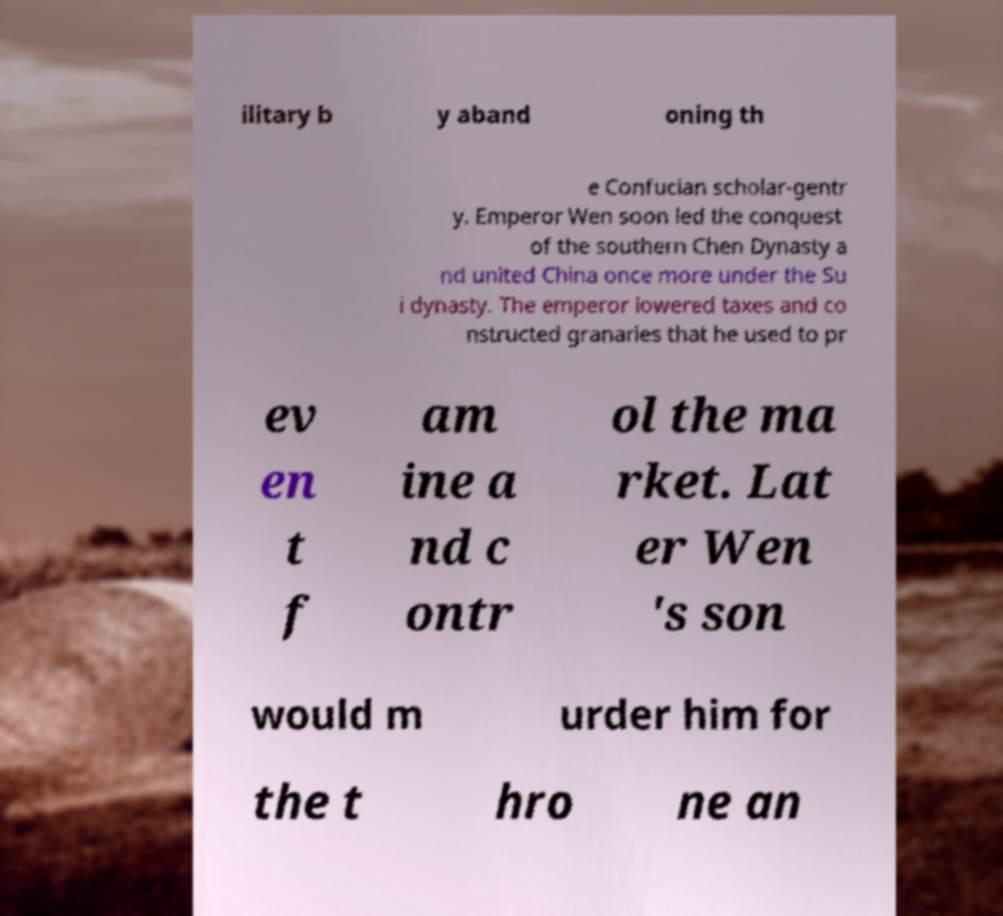Can you accurately transcribe the text from the provided image for me? ilitary b y aband oning th e Confucian scholar-gentr y. Emperor Wen soon led the conquest of the southern Chen Dynasty a nd united China once more under the Su i dynasty. The emperor lowered taxes and co nstructed granaries that he used to pr ev en t f am ine a nd c ontr ol the ma rket. Lat er Wen 's son would m urder him for the t hro ne an 